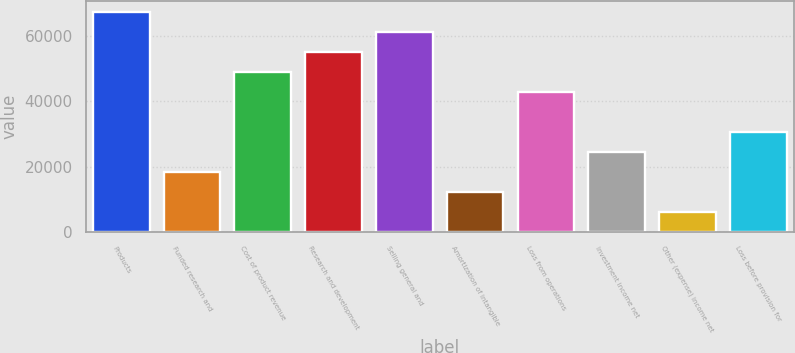Convert chart. <chart><loc_0><loc_0><loc_500><loc_500><bar_chart><fcel>Products<fcel>Funded research and<fcel>Cost of product revenue<fcel>Research and development<fcel>Selling general and<fcel>Amortization of intangible<fcel>Loss from operations<fcel>Investment income net<fcel>Other (expense) income net<fcel>Loss before provision for<nl><fcel>67167.1<fcel>18318.4<fcel>48848.8<fcel>54954.9<fcel>61061<fcel>12212.3<fcel>42742.7<fcel>24424.5<fcel>6106.2<fcel>30530.6<nl></chart> 